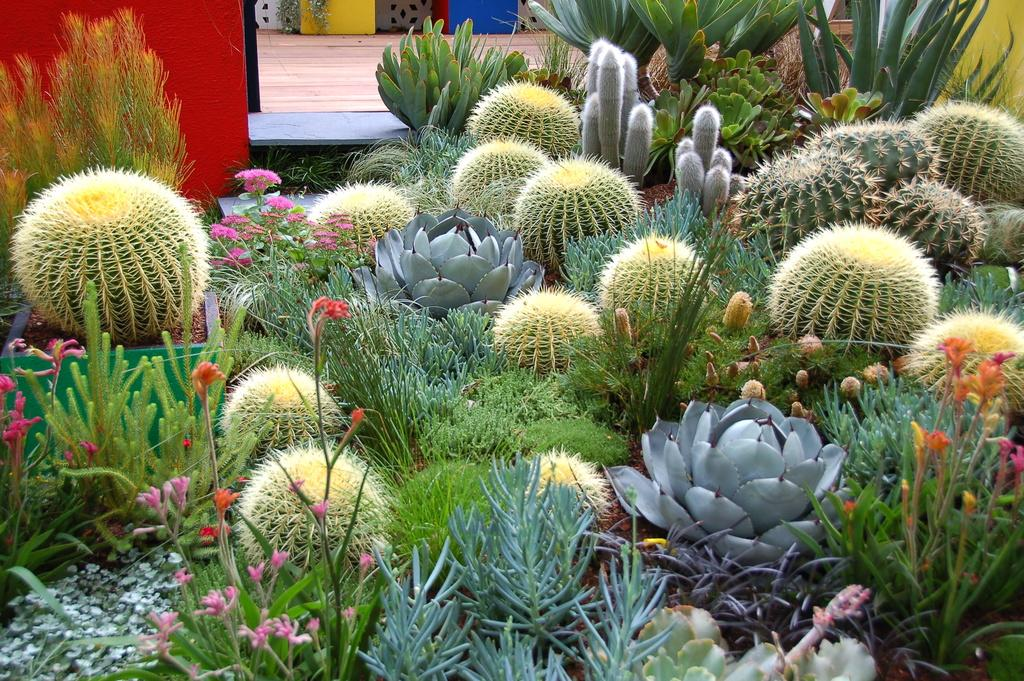What type of plants can be seen in the image? The image contains cactus plants and flowers. What other types of plants are present in the image? The image contains a variety of plants. What is visible at the top of the image? There is a pavement and a wall at the top of the image. What type of owl can be seen sitting on the toys in the image? There are no owls or toys present in the image. What type of property is visible in the image? The image does not show any property; it contains plants, a pavement, and a wall. 